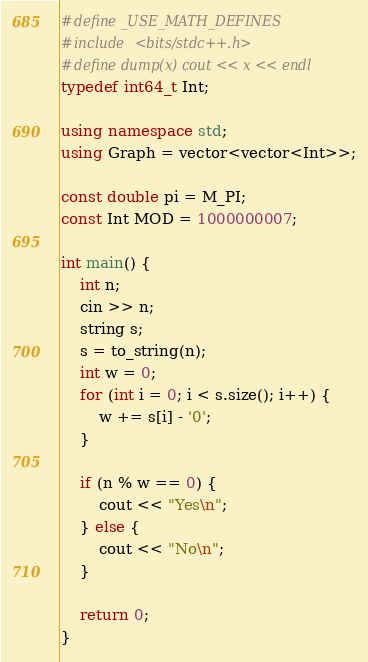<code> <loc_0><loc_0><loc_500><loc_500><_C++_>#define _USE_MATH_DEFINES
#include <bits/stdc++.h>
#define dump(x) cout << x << endl
typedef int64_t Int;

using namespace std;
using Graph = vector<vector<Int>>;

const double pi = M_PI;
const Int MOD = 1000000007;

int main() {
    int n;
    cin >> n;
    string s;
    s = to_string(n);
    int w = 0;
    for (int i = 0; i < s.size(); i++) {
        w += s[i] - '0';
    }

    if (n % w == 0) {
        cout << "Yes\n";
    } else {
        cout << "No\n";
    }

    return 0;
}
</code> 